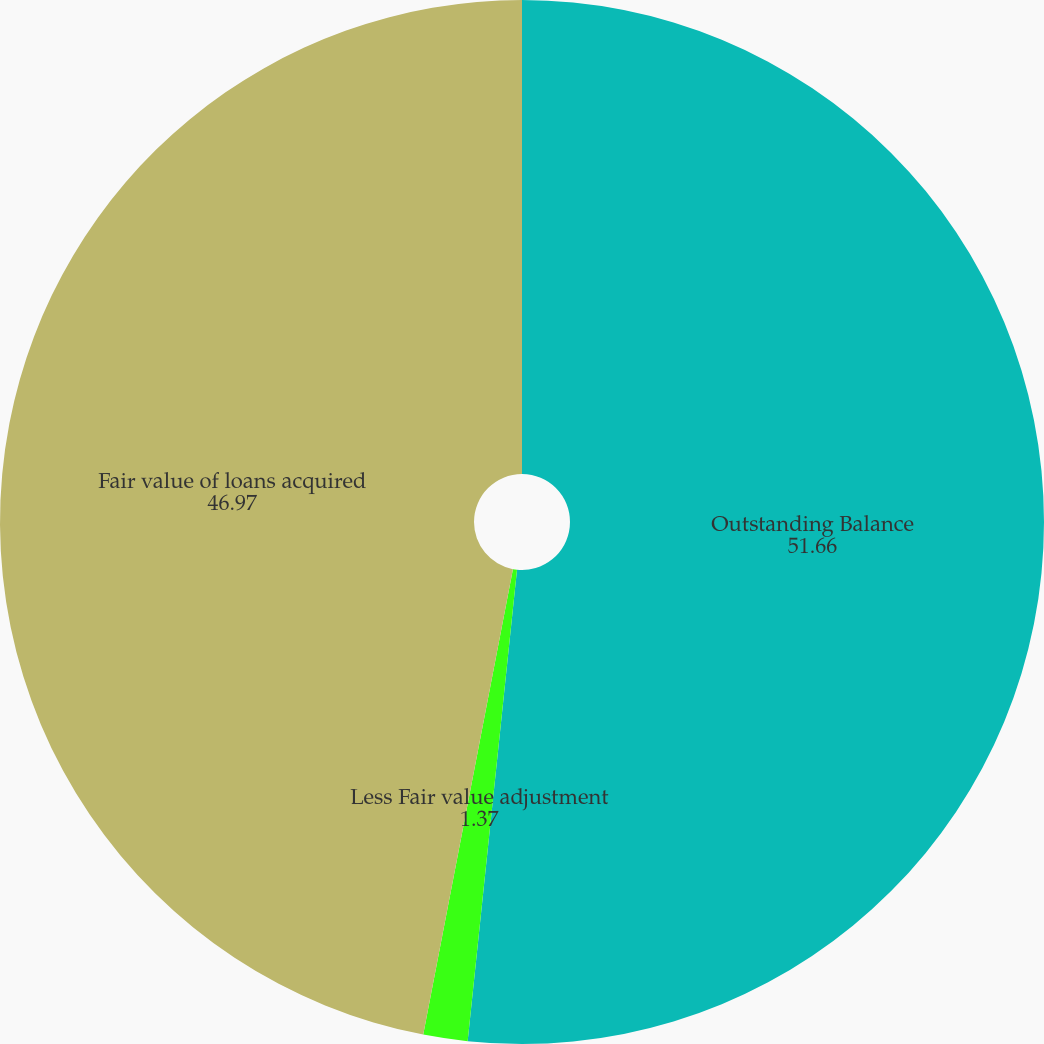Convert chart. <chart><loc_0><loc_0><loc_500><loc_500><pie_chart><fcel>Outstanding Balance<fcel>Less Fair value adjustment<fcel>Fair value of loans acquired<nl><fcel>51.66%<fcel>1.37%<fcel>46.97%<nl></chart> 